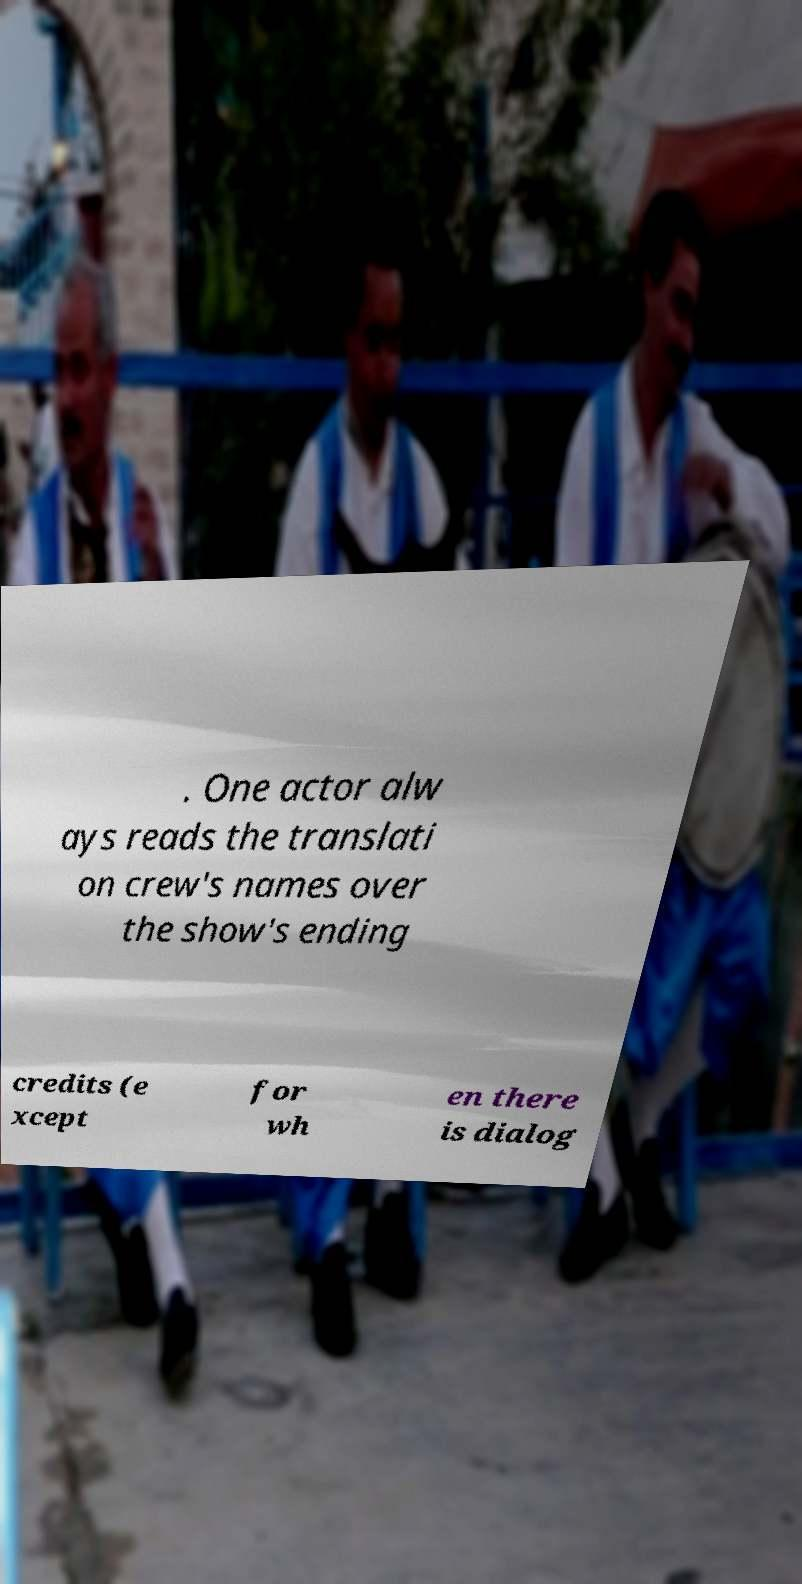Please read and relay the text visible in this image. What does it say? . One actor alw ays reads the translati on crew's names over the show's ending credits (e xcept for wh en there is dialog 